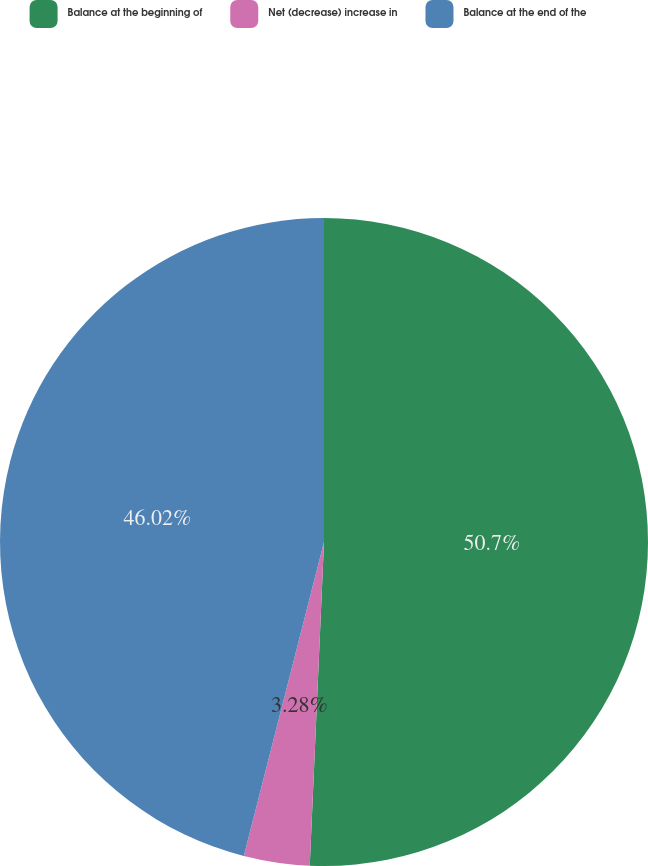<chart> <loc_0><loc_0><loc_500><loc_500><pie_chart><fcel>Balance at the beginning of<fcel>Net (decrease) increase in<fcel>Balance at the end of the<nl><fcel>50.7%<fcel>3.28%<fcel>46.02%<nl></chart> 